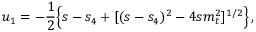Convert formula to latex. <formula><loc_0><loc_0><loc_500><loc_500>u _ { 1 } = - \frac { 1 } { 2 } \left \{ s - s _ { 4 } + [ ( s - s _ { 4 } ) ^ { 2 } - 4 s m _ { t } ^ { 2 } ] ^ { 1 / 2 } \right \} \, ,</formula> 